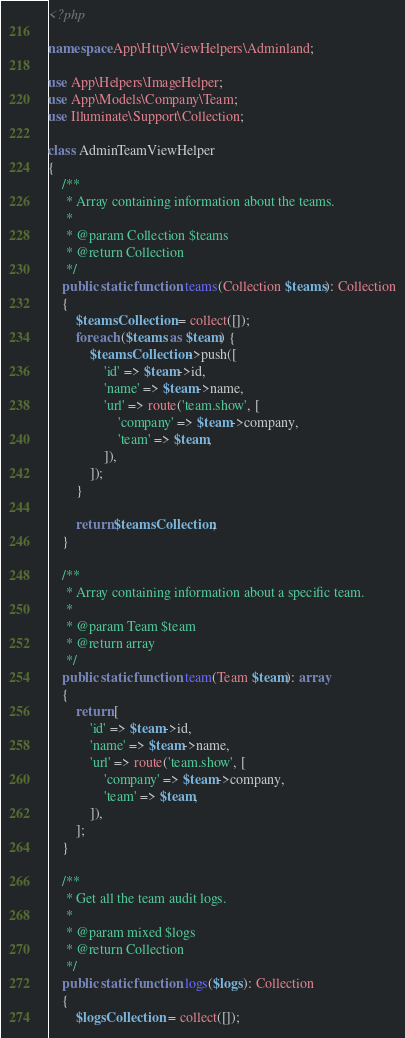<code> <loc_0><loc_0><loc_500><loc_500><_PHP_><?php

namespace App\Http\ViewHelpers\Adminland;

use App\Helpers\ImageHelper;
use App\Models\Company\Team;
use Illuminate\Support\Collection;

class AdminTeamViewHelper
{
    /**
     * Array containing information about the teams.
     *
     * @param Collection $teams
     * @return Collection
     */
    public static function teams(Collection $teams): Collection
    {
        $teamsCollection = collect([]);
        foreach ($teams as $team) {
            $teamsCollection->push([
                'id' => $team->id,
                'name' => $team->name,
                'url' => route('team.show', [
                    'company' => $team->company,
                    'team' => $team,
                ]),
            ]);
        }

        return $teamsCollection;
    }

    /**
     * Array containing information about a specific team.
     *
     * @param Team $team
     * @return array
     */
    public static function team(Team $team): array
    {
        return [
            'id' => $team->id,
            'name' => $team->name,
            'url' => route('team.show', [
                'company' => $team->company,
                'team' => $team,
            ]),
        ];
    }

    /**
     * Get all the team audit logs.
     *
     * @param mixed $logs
     * @return Collection
     */
    public static function logs($logs): Collection
    {
        $logsCollection = collect([]);</code> 